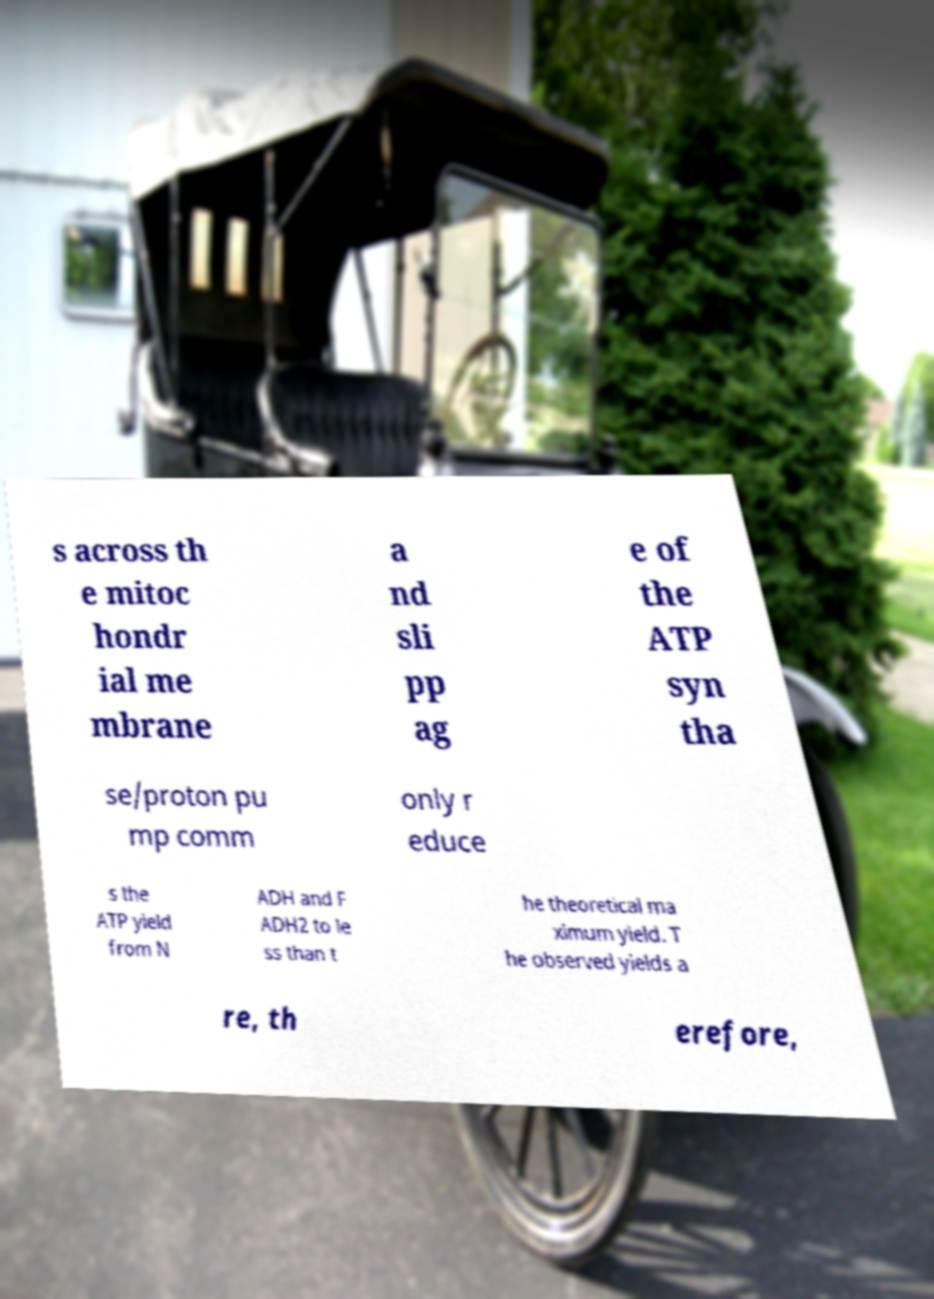Can you accurately transcribe the text from the provided image for me? s across th e mitoc hondr ial me mbrane a nd sli pp ag e of the ATP syn tha se/proton pu mp comm only r educe s the ATP yield from N ADH and F ADH2 to le ss than t he theoretical ma ximum yield. T he observed yields a re, th erefore, 